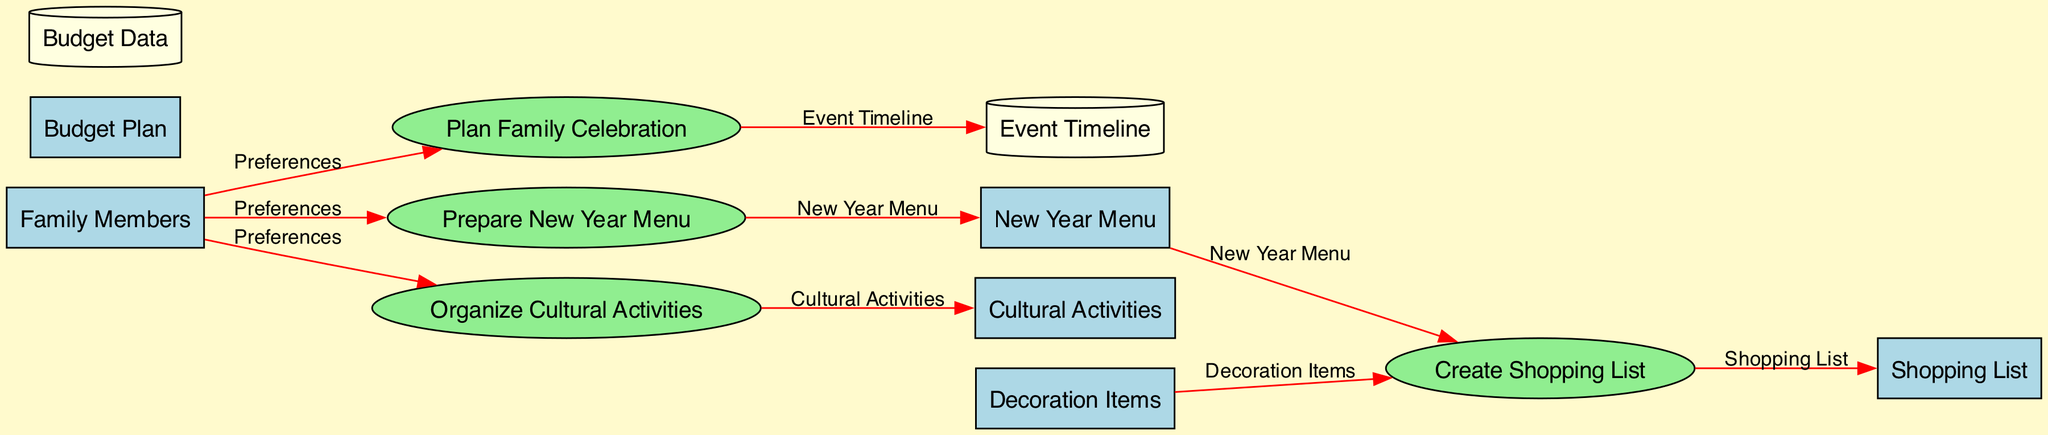What is the input for the "Plan Family Celebration" process? The input for the "Plan Family Celebration" process consists of "Family Members", "Preferences", and "Budget Plan". The first two are specifically relevant here as they denote personal choices affecting the celebration.
Answer: Family Members, Preferences, Budget Plan How many processes are in the diagram? By counting the items listed under the "Processes" section, we see there are four distinct processes: "Plan Family Celebration", "Prepare New Year Menu", "Create Shopping List", and "Organize Cultural Activities".
Answer: 4 Which entity is involved in creating a shopping list? The "Create Shopping List" process receives inputs from the "New Year Menu" and "Decoration Items". This indicates that it integrates information from both these entities to formulate a comprehensive shopping list.
Answer: New Year Menu, Decoration Items What is the output of the "Organize Cultural Activities" process? The "Organize Cultural Activities" process produces "Cultural Activities" as its output. This reflects the culmination of planning which includes the chosen activities for the family celebration.
Answer: Cultural Activities What flows from "Prepare New Year Menu" to "New Year Menu"? The flow of information from the "Prepare New Year Menu" process to the "New Year Menu" entity is labeled "New Year Menu". This means the output of the preparation process directly defines the menu for the celebration.
Answer: New Year Menu Which data store captures the event timeline? The data store named "Event Timeline" holds the planned schedule related to the family's celebration activities. This entity is essential for keeping track of when events will occur during the festivities.
Answer: Event Timeline What is needed to organize cultural activities? To organize cultural activities, the process requires inputs from the "Family Members" and their "Preferences". This indicates a personalized approach to ensuring activities reflect the family's desires.
Answer: Family Members, Preferences What is the relationship between "Family Members" and "Cultural Activities"? The "Family Members" provide their "Preferences" to the "Organize Cultural Activities" process, shaping the output to align with their interests, ensuring that the activities are enjoyed by everyone.
Answer: Preferences How many data stores are specified in the diagram? There are two data stores mentioned in the diagram: "Budget Data" and "Event Timeline". These stores are used to manage critical data related to the planning process.
Answer: 2 